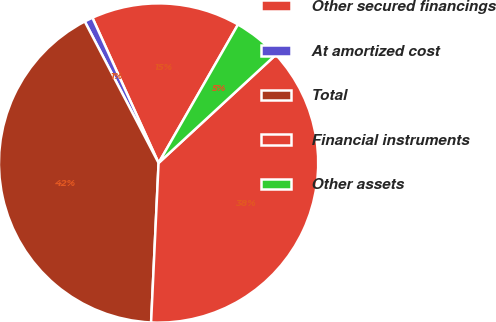<chart> <loc_0><loc_0><loc_500><loc_500><pie_chart><fcel>Other secured financings<fcel>At amortized cost<fcel>Total<fcel>Financial instruments<fcel>Other assets<nl><fcel>15.09%<fcel>0.85%<fcel>41.6%<fcel>37.61%<fcel>4.85%<nl></chart> 